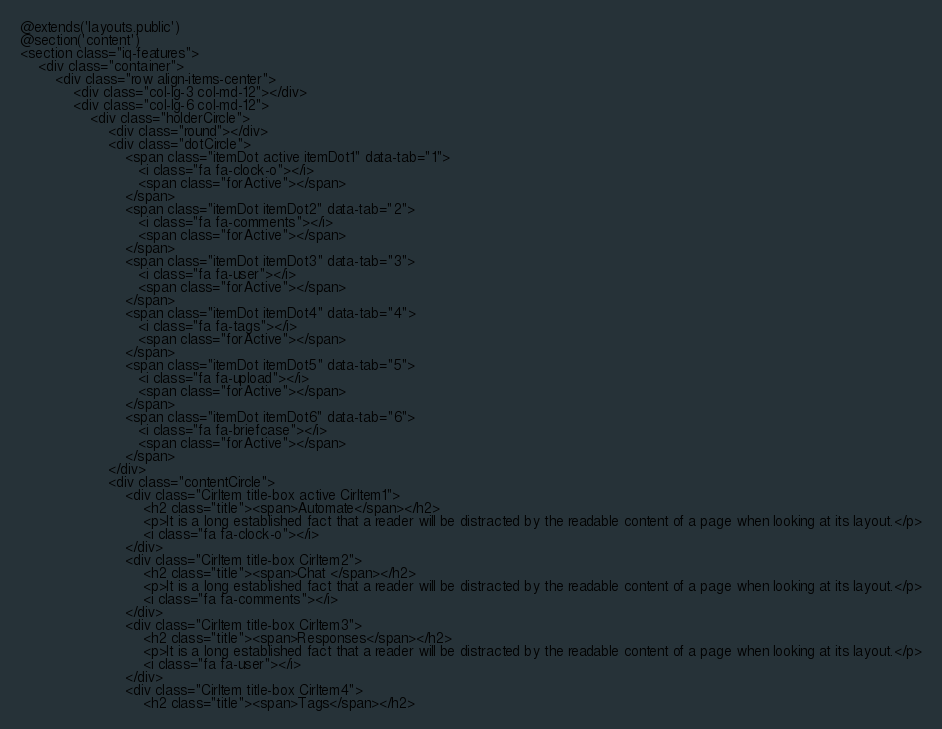Convert code to text. <code><loc_0><loc_0><loc_500><loc_500><_PHP_>@extends('layouts.public')
@section('content')
<section class="iq-features">
    <div class="container">
        <div class="row align-items-center">
            <div class="col-lg-3 col-md-12"></div>
            <div class="col-lg-6 col-md-12">
                <div class="holderCircle">
                    <div class="round"></div>
                    <div class="dotCircle">
                        <span class="itemDot active itemDot1" data-tab="1">
                           <i class="fa fa-clock-o"></i>
                           <span class="forActive"></span>
                        </span>
                        <span class="itemDot itemDot2" data-tab="2">
                           <i class="fa fa-comments"></i>
                           <span class="forActive"></span>
                        </span>
                        <span class="itemDot itemDot3" data-tab="3">
                           <i class="fa fa-user"></i>
                           <span class="forActive"></span>
                        </span>
                        <span class="itemDot itemDot4" data-tab="4">
                           <i class="fa fa-tags"></i>
                           <span class="forActive"></span>
                        </span>
                        <span class="itemDot itemDot5" data-tab="5">
                           <i class="fa fa-upload"></i>
                           <span class="forActive"></span>
                        </span>
                        <span class="itemDot itemDot6" data-tab="6">
                           <i class="fa fa-briefcase"></i>
                           <span class="forActive"></span>
                        </span>
                    </div>
                    <div class="contentCircle">
                        <div class="CirItem title-box active CirItem1">
                            <h2 class="title"><span>Automate</span></h2>
                            <p>It is a long established fact that a reader will be distracted by the readable content of a page when looking at its layout.</p>
                            <i class="fa fa-clock-o"></i>
                        </div>
                        <div class="CirItem title-box CirItem2">
                            <h2 class="title"><span>Chat </span></h2>
                            <p>It is a long established fact that a reader will be distracted by the readable content of a page when looking at its layout.</p>
                            <i class="fa fa-comments"></i>
                        </div>
                        <div class="CirItem title-box CirItem3">
                            <h2 class="title"><span>Responses</span></h2>
                            <p>It is a long established fact that a reader will be distracted by the readable content of a page when looking at its layout.</p>
                            <i class="fa fa-user"></i>
                        </div>
                        <div class="CirItem title-box CirItem4">
                            <h2 class="title"><span>Tags</span></h2></code> 